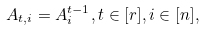Convert formula to latex. <formula><loc_0><loc_0><loc_500><loc_500>A _ { t , i } = A _ { i } ^ { t - 1 } , t \in [ r ] , i \in [ n ] ,</formula> 